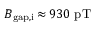Convert formula to latex. <formula><loc_0><loc_0><loc_500><loc_500>B _ { g a p , i } \, { \approx } \, 9 3 0 p T</formula> 